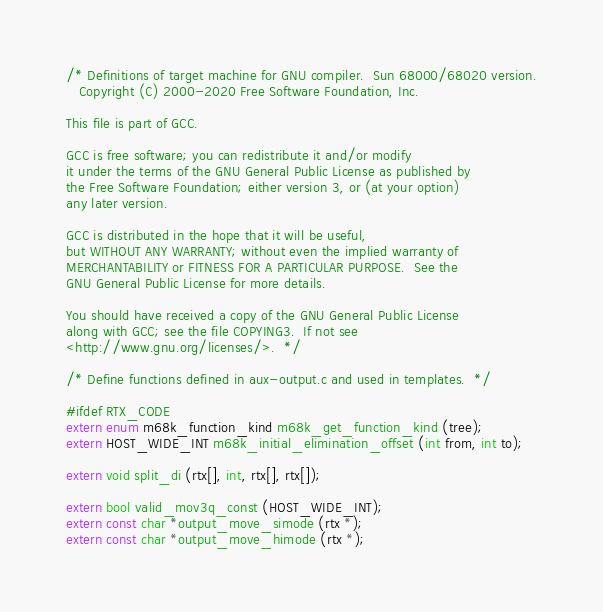<code> <loc_0><loc_0><loc_500><loc_500><_C_>/* Definitions of target machine for GNU compiler.  Sun 68000/68020 version.
   Copyright (C) 2000-2020 Free Software Foundation, Inc.

This file is part of GCC.

GCC is free software; you can redistribute it and/or modify
it under the terms of the GNU General Public License as published by
the Free Software Foundation; either version 3, or (at your option)
any later version.

GCC is distributed in the hope that it will be useful,
but WITHOUT ANY WARRANTY; without even the implied warranty of
MERCHANTABILITY or FITNESS FOR A PARTICULAR PURPOSE.  See the
GNU General Public License for more details.

You should have received a copy of the GNU General Public License
along with GCC; see the file COPYING3.  If not see
<http://www.gnu.org/licenses/>.  */

/* Define functions defined in aux-output.c and used in templates.  */

#ifdef RTX_CODE
extern enum m68k_function_kind m68k_get_function_kind (tree);
extern HOST_WIDE_INT m68k_initial_elimination_offset (int from, int to);

extern void split_di (rtx[], int, rtx[], rtx[]);

extern bool valid_mov3q_const (HOST_WIDE_INT);
extern const char *output_move_simode (rtx *);
extern const char *output_move_himode (rtx *);</code> 